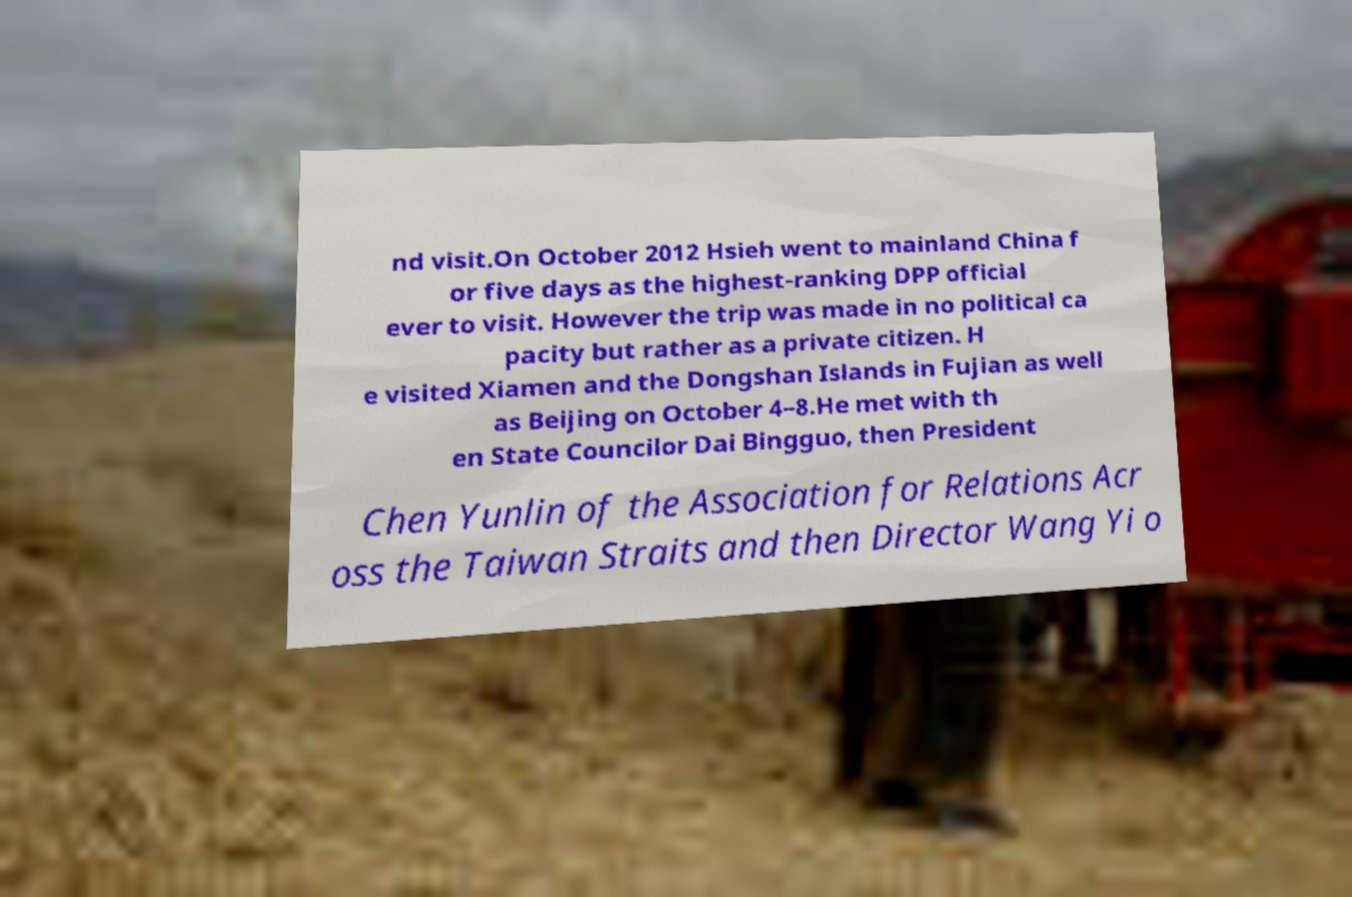What messages or text are displayed in this image? I need them in a readable, typed format. nd visit.On October 2012 Hsieh went to mainland China f or five days as the highest-ranking DPP official ever to visit. However the trip was made in no political ca pacity but rather as a private citizen. H e visited Xiamen and the Dongshan Islands in Fujian as well as Beijing on October 4–8.He met with th en State Councilor Dai Bingguo, then President Chen Yunlin of the Association for Relations Acr oss the Taiwan Straits and then Director Wang Yi o 